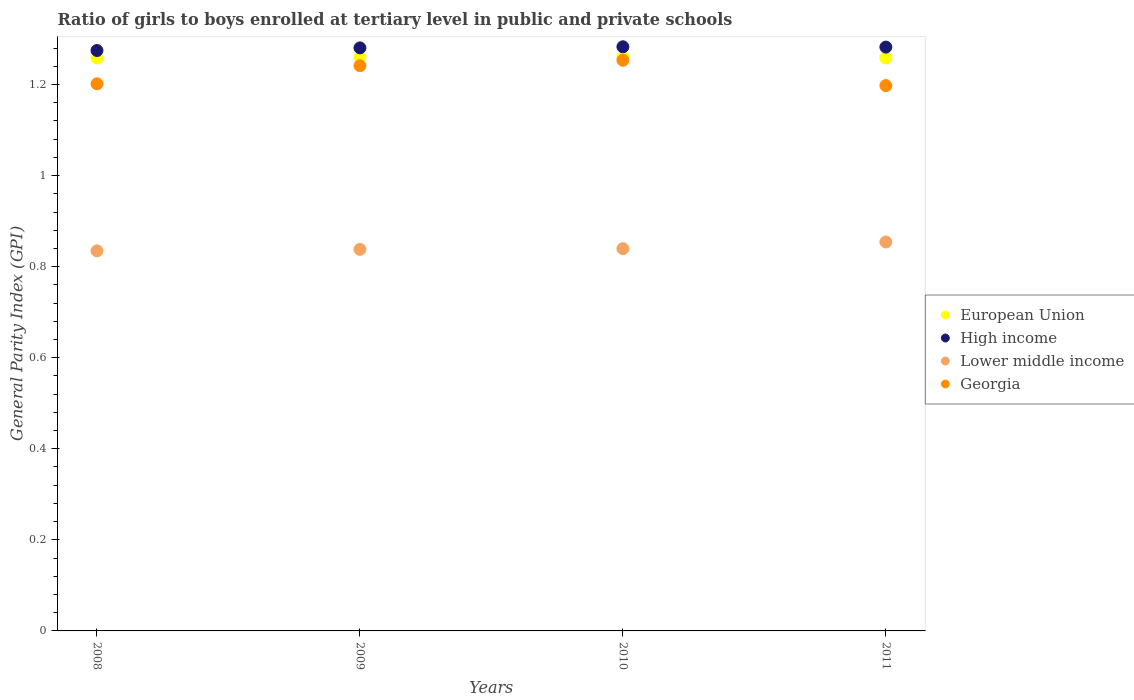How many different coloured dotlines are there?
Your answer should be very brief. 4. What is the general parity index in European Union in 2008?
Offer a terse response. 1.26. Across all years, what is the maximum general parity index in Lower middle income?
Your answer should be very brief. 0.85. Across all years, what is the minimum general parity index in High income?
Provide a succinct answer. 1.27. In which year was the general parity index in High income minimum?
Ensure brevity in your answer.  2008. What is the total general parity index in High income in the graph?
Your response must be concise. 5.12. What is the difference between the general parity index in European Union in 2008 and that in 2010?
Give a very brief answer. -0. What is the difference between the general parity index in Georgia in 2009 and the general parity index in Lower middle income in 2010?
Ensure brevity in your answer.  0.4. What is the average general parity index in Georgia per year?
Provide a succinct answer. 1.22. In the year 2011, what is the difference between the general parity index in European Union and general parity index in High income?
Your answer should be compact. -0.02. In how many years, is the general parity index in European Union greater than 0.6000000000000001?
Your response must be concise. 4. What is the ratio of the general parity index in Georgia in 2009 to that in 2011?
Offer a terse response. 1.04. Is the difference between the general parity index in European Union in 2009 and 2010 greater than the difference between the general parity index in High income in 2009 and 2010?
Ensure brevity in your answer.  Yes. What is the difference between the highest and the second highest general parity index in High income?
Keep it short and to the point. 0. What is the difference between the highest and the lowest general parity index in European Union?
Provide a succinct answer. 0. Does the general parity index in Georgia monotonically increase over the years?
Provide a succinct answer. No. Is the general parity index in Lower middle income strictly greater than the general parity index in Georgia over the years?
Keep it short and to the point. No. How many years are there in the graph?
Your response must be concise. 4. What is the difference between two consecutive major ticks on the Y-axis?
Ensure brevity in your answer.  0.2. Does the graph contain any zero values?
Offer a terse response. No. Does the graph contain grids?
Your answer should be compact. No. How many legend labels are there?
Your response must be concise. 4. How are the legend labels stacked?
Provide a succinct answer. Vertical. What is the title of the graph?
Keep it short and to the point. Ratio of girls to boys enrolled at tertiary level in public and private schools. Does "Macao" appear as one of the legend labels in the graph?
Offer a very short reply. No. What is the label or title of the X-axis?
Provide a short and direct response. Years. What is the label or title of the Y-axis?
Offer a terse response. General Parity Index (GPI). What is the General Parity Index (GPI) of European Union in 2008?
Ensure brevity in your answer.  1.26. What is the General Parity Index (GPI) of High income in 2008?
Provide a succinct answer. 1.27. What is the General Parity Index (GPI) of Lower middle income in 2008?
Your answer should be compact. 0.83. What is the General Parity Index (GPI) in Georgia in 2008?
Your answer should be compact. 1.2. What is the General Parity Index (GPI) in European Union in 2009?
Make the answer very short. 1.26. What is the General Parity Index (GPI) of High income in 2009?
Give a very brief answer. 1.28. What is the General Parity Index (GPI) in Lower middle income in 2009?
Make the answer very short. 0.84. What is the General Parity Index (GPI) in Georgia in 2009?
Your answer should be compact. 1.24. What is the General Parity Index (GPI) in European Union in 2010?
Give a very brief answer. 1.26. What is the General Parity Index (GPI) in High income in 2010?
Keep it short and to the point. 1.28. What is the General Parity Index (GPI) in Lower middle income in 2010?
Your answer should be compact. 0.84. What is the General Parity Index (GPI) in Georgia in 2010?
Provide a short and direct response. 1.25. What is the General Parity Index (GPI) in European Union in 2011?
Keep it short and to the point. 1.26. What is the General Parity Index (GPI) of High income in 2011?
Give a very brief answer. 1.28. What is the General Parity Index (GPI) of Lower middle income in 2011?
Offer a terse response. 0.85. What is the General Parity Index (GPI) in Georgia in 2011?
Your answer should be compact. 1.2. Across all years, what is the maximum General Parity Index (GPI) of European Union?
Provide a short and direct response. 1.26. Across all years, what is the maximum General Parity Index (GPI) in High income?
Offer a terse response. 1.28. Across all years, what is the maximum General Parity Index (GPI) in Lower middle income?
Your response must be concise. 0.85. Across all years, what is the maximum General Parity Index (GPI) of Georgia?
Make the answer very short. 1.25. Across all years, what is the minimum General Parity Index (GPI) in European Union?
Offer a terse response. 1.26. Across all years, what is the minimum General Parity Index (GPI) in High income?
Offer a terse response. 1.27. Across all years, what is the minimum General Parity Index (GPI) in Lower middle income?
Give a very brief answer. 0.83. Across all years, what is the minimum General Parity Index (GPI) of Georgia?
Give a very brief answer. 1.2. What is the total General Parity Index (GPI) in European Union in the graph?
Make the answer very short. 5.04. What is the total General Parity Index (GPI) of High income in the graph?
Keep it short and to the point. 5.12. What is the total General Parity Index (GPI) in Lower middle income in the graph?
Your answer should be compact. 3.37. What is the total General Parity Index (GPI) in Georgia in the graph?
Make the answer very short. 4.89. What is the difference between the General Parity Index (GPI) in European Union in 2008 and that in 2009?
Ensure brevity in your answer.  -0. What is the difference between the General Parity Index (GPI) in High income in 2008 and that in 2009?
Offer a terse response. -0.01. What is the difference between the General Parity Index (GPI) of Lower middle income in 2008 and that in 2009?
Provide a short and direct response. -0. What is the difference between the General Parity Index (GPI) in Georgia in 2008 and that in 2009?
Your response must be concise. -0.04. What is the difference between the General Parity Index (GPI) in European Union in 2008 and that in 2010?
Provide a succinct answer. -0. What is the difference between the General Parity Index (GPI) of High income in 2008 and that in 2010?
Provide a short and direct response. -0.01. What is the difference between the General Parity Index (GPI) of Lower middle income in 2008 and that in 2010?
Offer a very short reply. -0. What is the difference between the General Parity Index (GPI) in Georgia in 2008 and that in 2010?
Make the answer very short. -0.05. What is the difference between the General Parity Index (GPI) of High income in 2008 and that in 2011?
Your answer should be very brief. -0.01. What is the difference between the General Parity Index (GPI) in Lower middle income in 2008 and that in 2011?
Your answer should be very brief. -0.02. What is the difference between the General Parity Index (GPI) in Georgia in 2008 and that in 2011?
Your answer should be very brief. 0. What is the difference between the General Parity Index (GPI) in European Union in 2009 and that in 2010?
Provide a succinct answer. -0. What is the difference between the General Parity Index (GPI) of High income in 2009 and that in 2010?
Make the answer very short. -0. What is the difference between the General Parity Index (GPI) in Lower middle income in 2009 and that in 2010?
Offer a very short reply. -0. What is the difference between the General Parity Index (GPI) of Georgia in 2009 and that in 2010?
Offer a terse response. -0.01. What is the difference between the General Parity Index (GPI) of European Union in 2009 and that in 2011?
Provide a succinct answer. 0. What is the difference between the General Parity Index (GPI) of High income in 2009 and that in 2011?
Provide a short and direct response. -0. What is the difference between the General Parity Index (GPI) in Lower middle income in 2009 and that in 2011?
Provide a short and direct response. -0.02. What is the difference between the General Parity Index (GPI) in Georgia in 2009 and that in 2011?
Offer a terse response. 0.04. What is the difference between the General Parity Index (GPI) of European Union in 2010 and that in 2011?
Give a very brief answer. 0. What is the difference between the General Parity Index (GPI) in High income in 2010 and that in 2011?
Your answer should be very brief. 0. What is the difference between the General Parity Index (GPI) in Lower middle income in 2010 and that in 2011?
Provide a succinct answer. -0.01. What is the difference between the General Parity Index (GPI) in Georgia in 2010 and that in 2011?
Give a very brief answer. 0.06. What is the difference between the General Parity Index (GPI) of European Union in 2008 and the General Parity Index (GPI) of High income in 2009?
Keep it short and to the point. -0.02. What is the difference between the General Parity Index (GPI) in European Union in 2008 and the General Parity Index (GPI) in Lower middle income in 2009?
Your answer should be compact. 0.42. What is the difference between the General Parity Index (GPI) of European Union in 2008 and the General Parity Index (GPI) of Georgia in 2009?
Your answer should be very brief. 0.02. What is the difference between the General Parity Index (GPI) of High income in 2008 and the General Parity Index (GPI) of Lower middle income in 2009?
Keep it short and to the point. 0.44. What is the difference between the General Parity Index (GPI) in High income in 2008 and the General Parity Index (GPI) in Georgia in 2009?
Provide a succinct answer. 0.03. What is the difference between the General Parity Index (GPI) of Lower middle income in 2008 and the General Parity Index (GPI) of Georgia in 2009?
Make the answer very short. -0.41. What is the difference between the General Parity Index (GPI) of European Union in 2008 and the General Parity Index (GPI) of High income in 2010?
Ensure brevity in your answer.  -0.02. What is the difference between the General Parity Index (GPI) of European Union in 2008 and the General Parity Index (GPI) of Lower middle income in 2010?
Your answer should be compact. 0.42. What is the difference between the General Parity Index (GPI) of European Union in 2008 and the General Parity Index (GPI) of Georgia in 2010?
Your answer should be compact. 0.01. What is the difference between the General Parity Index (GPI) in High income in 2008 and the General Parity Index (GPI) in Lower middle income in 2010?
Ensure brevity in your answer.  0.44. What is the difference between the General Parity Index (GPI) in High income in 2008 and the General Parity Index (GPI) in Georgia in 2010?
Provide a short and direct response. 0.02. What is the difference between the General Parity Index (GPI) of Lower middle income in 2008 and the General Parity Index (GPI) of Georgia in 2010?
Keep it short and to the point. -0.42. What is the difference between the General Parity Index (GPI) of European Union in 2008 and the General Parity Index (GPI) of High income in 2011?
Provide a succinct answer. -0.02. What is the difference between the General Parity Index (GPI) of European Union in 2008 and the General Parity Index (GPI) of Lower middle income in 2011?
Offer a very short reply. 0.4. What is the difference between the General Parity Index (GPI) in European Union in 2008 and the General Parity Index (GPI) in Georgia in 2011?
Make the answer very short. 0.06. What is the difference between the General Parity Index (GPI) in High income in 2008 and the General Parity Index (GPI) in Lower middle income in 2011?
Offer a terse response. 0.42. What is the difference between the General Parity Index (GPI) in High income in 2008 and the General Parity Index (GPI) in Georgia in 2011?
Offer a very short reply. 0.08. What is the difference between the General Parity Index (GPI) of Lower middle income in 2008 and the General Parity Index (GPI) of Georgia in 2011?
Provide a short and direct response. -0.36. What is the difference between the General Parity Index (GPI) of European Union in 2009 and the General Parity Index (GPI) of High income in 2010?
Provide a succinct answer. -0.02. What is the difference between the General Parity Index (GPI) in European Union in 2009 and the General Parity Index (GPI) in Lower middle income in 2010?
Give a very brief answer. 0.42. What is the difference between the General Parity Index (GPI) of European Union in 2009 and the General Parity Index (GPI) of Georgia in 2010?
Provide a succinct answer. 0.01. What is the difference between the General Parity Index (GPI) in High income in 2009 and the General Parity Index (GPI) in Lower middle income in 2010?
Provide a succinct answer. 0.44. What is the difference between the General Parity Index (GPI) in High income in 2009 and the General Parity Index (GPI) in Georgia in 2010?
Provide a short and direct response. 0.03. What is the difference between the General Parity Index (GPI) of Lower middle income in 2009 and the General Parity Index (GPI) of Georgia in 2010?
Your answer should be very brief. -0.42. What is the difference between the General Parity Index (GPI) of European Union in 2009 and the General Parity Index (GPI) of High income in 2011?
Your answer should be compact. -0.02. What is the difference between the General Parity Index (GPI) of European Union in 2009 and the General Parity Index (GPI) of Lower middle income in 2011?
Keep it short and to the point. 0.41. What is the difference between the General Parity Index (GPI) in European Union in 2009 and the General Parity Index (GPI) in Georgia in 2011?
Make the answer very short. 0.06. What is the difference between the General Parity Index (GPI) in High income in 2009 and the General Parity Index (GPI) in Lower middle income in 2011?
Your response must be concise. 0.43. What is the difference between the General Parity Index (GPI) in High income in 2009 and the General Parity Index (GPI) in Georgia in 2011?
Your answer should be compact. 0.08. What is the difference between the General Parity Index (GPI) of Lower middle income in 2009 and the General Parity Index (GPI) of Georgia in 2011?
Give a very brief answer. -0.36. What is the difference between the General Parity Index (GPI) of European Union in 2010 and the General Parity Index (GPI) of High income in 2011?
Give a very brief answer. -0.02. What is the difference between the General Parity Index (GPI) of European Union in 2010 and the General Parity Index (GPI) of Lower middle income in 2011?
Offer a terse response. 0.41. What is the difference between the General Parity Index (GPI) of European Union in 2010 and the General Parity Index (GPI) of Georgia in 2011?
Your response must be concise. 0.06. What is the difference between the General Parity Index (GPI) in High income in 2010 and the General Parity Index (GPI) in Lower middle income in 2011?
Your answer should be very brief. 0.43. What is the difference between the General Parity Index (GPI) of High income in 2010 and the General Parity Index (GPI) of Georgia in 2011?
Provide a short and direct response. 0.09. What is the difference between the General Parity Index (GPI) of Lower middle income in 2010 and the General Parity Index (GPI) of Georgia in 2011?
Offer a terse response. -0.36. What is the average General Parity Index (GPI) in European Union per year?
Provide a short and direct response. 1.26. What is the average General Parity Index (GPI) in High income per year?
Make the answer very short. 1.28. What is the average General Parity Index (GPI) of Lower middle income per year?
Your answer should be compact. 0.84. What is the average General Parity Index (GPI) of Georgia per year?
Your answer should be very brief. 1.22. In the year 2008, what is the difference between the General Parity Index (GPI) in European Union and General Parity Index (GPI) in High income?
Your answer should be very brief. -0.02. In the year 2008, what is the difference between the General Parity Index (GPI) of European Union and General Parity Index (GPI) of Lower middle income?
Make the answer very short. 0.42. In the year 2008, what is the difference between the General Parity Index (GPI) in European Union and General Parity Index (GPI) in Georgia?
Ensure brevity in your answer.  0.06. In the year 2008, what is the difference between the General Parity Index (GPI) of High income and General Parity Index (GPI) of Lower middle income?
Keep it short and to the point. 0.44. In the year 2008, what is the difference between the General Parity Index (GPI) of High income and General Parity Index (GPI) of Georgia?
Provide a short and direct response. 0.07. In the year 2008, what is the difference between the General Parity Index (GPI) of Lower middle income and General Parity Index (GPI) of Georgia?
Provide a succinct answer. -0.37. In the year 2009, what is the difference between the General Parity Index (GPI) in European Union and General Parity Index (GPI) in High income?
Give a very brief answer. -0.02. In the year 2009, what is the difference between the General Parity Index (GPI) of European Union and General Parity Index (GPI) of Lower middle income?
Provide a succinct answer. 0.42. In the year 2009, what is the difference between the General Parity Index (GPI) of European Union and General Parity Index (GPI) of Georgia?
Your answer should be compact. 0.02. In the year 2009, what is the difference between the General Parity Index (GPI) of High income and General Parity Index (GPI) of Lower middle income?
Offer a very short reply. 0.44. In the year 2009, what is the difference between the General Parity Index (GPI) of High income and General Parity Index (GPI) of Georgia?
Your response must be concise. 0.04. In the year 2009, what is the difference between the General Parity Index (GPI) of Lower middle income and General Parity Index (GPI) of Georgia?
Your answer should be very brief. -0.4. In the year 2010, what is the difference between the General Parity Index (GPI) of European Union and General Parity Index (GPI) of High income?
Provide a succinct answer. -0.02. In the year 2010, what is the difference between the General Parity Index (GPI) in European Union and General Parity Index (GPI) in Lower middle income?
Your answer should be very brief. 0.42. In the year 2010, what is the difference between the General Parity Index (GPI) of European Union and General Parity Index (GPI) of Georgia?
Keep it short and to the point. 0.01. In the year 2010, what is the difference between the General Parity Index (GPI) of High income and General Parity Index (GPI) of Lower middle income?
Ensure brevity in your answer.  0.44. In the year 2010, what is the difference between the General Parity Index (GPI) of High income and General Parity Index (GPI) of Georgia?
Make the answer very short. 0.03. In the year 2010, what is the difference between the General Parity Index (GPI) in Lower middle income and General Parity Index (GPI) in Georgia?
Your response must be concise. -0.41. In the year 2011, what is the difference between the General Parity Index (GPI) of European Union and General Parity Index (GPI) of High income?
Ensure brevity in your answer.  -0.02. In the year 2011, what is the difference between the General Parity Index (GPI) of European Union and General Parity Index (GPI) of Lower middle income?
Keep it short and to the point. 0.4. In the year 2011, what is the difference between the General Parity Index (GPI) of European Union and General Parity Index (GPI) of Georgia?
Your answer should be compact. 0.06. In the year 2011, what is the difference between the General Parity Index (GPI) of High income and General Parity Index (GPI) of Lower middle income?
Offer a terse response. 0.43. In the year 2011, what is the difference between the General Parity Index (GPI) of High income and General Parity Index (GPI) of Georgia?
Offer a terse response. 0.08. In the year 2011, what is the difference between the General Parity Index (GPI) in Lower middle income and General Parity Index (GPI) in Georgia?
Provide a succinct answer. -0.34. What is the ratio of the General Parity Index (GPI) in High income in 2008 to that in 2010?
Give a very brief answer. 0.99. What is the ratio of the General Parity Index (GPI) in Georgia in 2008 to that in 2010?
Make the answer very short. 0.96. What is the ratio of the General Parity Index (GPI) in European Union in 2008 to that in 2011?
Your answer should be very brief. 1. What is the ratio of the General Parity Index (GPI) of Lower middle income in 2008 to that in 2011?
Your answer should be very brief. 0.98. What is the ratio of the General Parity Index (GPI) in Georgia in 2008 to that in 2011?
Your response must be concise. 1. What is the ratio of the General Parity Index (GPI) of European Union in 2009 to that in 2010?
Your answer should be very brief. 1. What is the ratio of the General Parity Index (GPI) of High income in 2009 to that in 2011?
Make the answer very short. 1. What is the ratio of the General Parity Index (GPI) of Georgia in 2009 to that in 2011?
Your response must be concise. 1.04. What is the ratio of the General Parity Index (GPI) of European Union in 2010 to that in 2011?
Provide a short and direct response. 1. What is the ratio of the General Parity Index (GPI) of Lower middle income in 2010 to that in 2011?
Keep it short and to the point. 0.98. What is the ratio of the General Parity Index (GPI) of Georgia in 2010 to that in 2011?
Your answer should be very brief. 1.05. What is the difference between the highest and the second highest General Parity Index (GPI) in High income?
Keep it short and to the point. 0. What is the difference between the highest and the second highest General Parity Index (GPI) of Lower middle income?
Make the answer very short. 0.01. What is the difference between the highest and the second highest General Parity Index (GPI) of Georgia?
Keep it short and to the point. 0.01. What is the difference between the highest and the lowest General Parity Index (GPI) in European Union?
Make the answer very short. 0. What is the difference between the highest and the lowest General Parity Index (GPI) in High income?
Your answer should be compact. 0.01. What is the difference between the highest and the lowest General Parity Index (GPI) of Lower middle income?
Keep it short and to the point. 0.02. What is the difference between the highest and the lowest General Parity Index (GPI) in Georgia?
Your answer should be very brief. 0.06. 